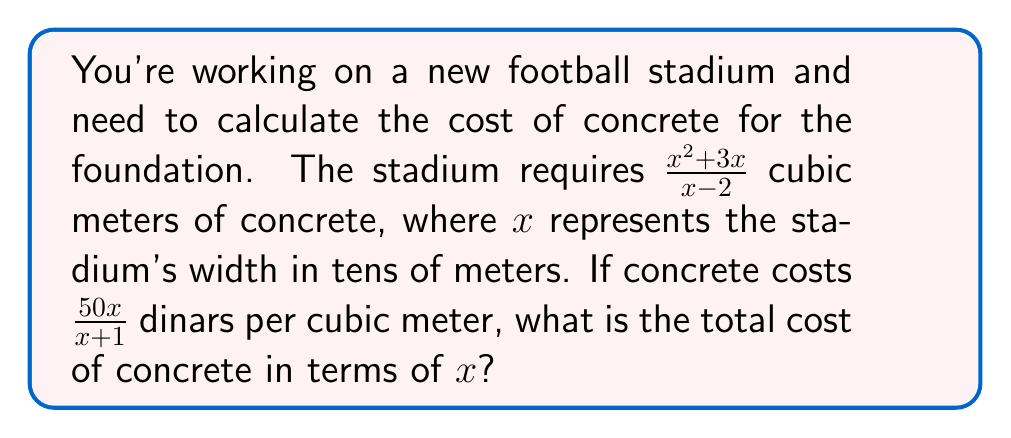Provide a solution to this math problem. Let's approach this step-by-step:

1) We need to multiply the volume of concrete by the cost per cubic meter. This means multiplying these two rational expressions:

   $$\frac{x^2 + 3x}{x - 2} \cdot \frac{50x}{x + 1}$$

2) To multiply rational expressions, we multiply the numerators and denominators separately:

   $$\frac{(x^2 + 3x) \cdot 50x}{(x - 2) \cdot (x + 1)}$$

3) Let's simplify the numerator:
   $$(x^2 + 3x) \cdot 50x = 50x^3 + 150x^2$$

4) The denominator doesn't need simplification, so our expression is now:

   $$\frac{50x^3 + 150x^2}{(x - 2)(x + 1)}$$

5) We can factor out 50x^2 from the numerator:

   $$\frac{50x^2(x + 3)}{(x - 2)(x + 1)}$$

This is our final expression for the total cost of concrete in terms of $x$.
Answer: $$\frac{50x^2(x + 3)}{(x - 2)(x + 1)}$$ dinars 